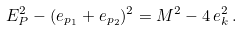Convert formula to latex. <formula><loc_0><loc_0><loc_500><loc_500>E _ { P } ^ { 2 } - ( e _ { p _ { 1 } } + e _ { p _ { 2 } } ) ^ { 2 } = M ^ { 2 } - 4 \, e _ { k } ^ { 2 } \, .</formula> 